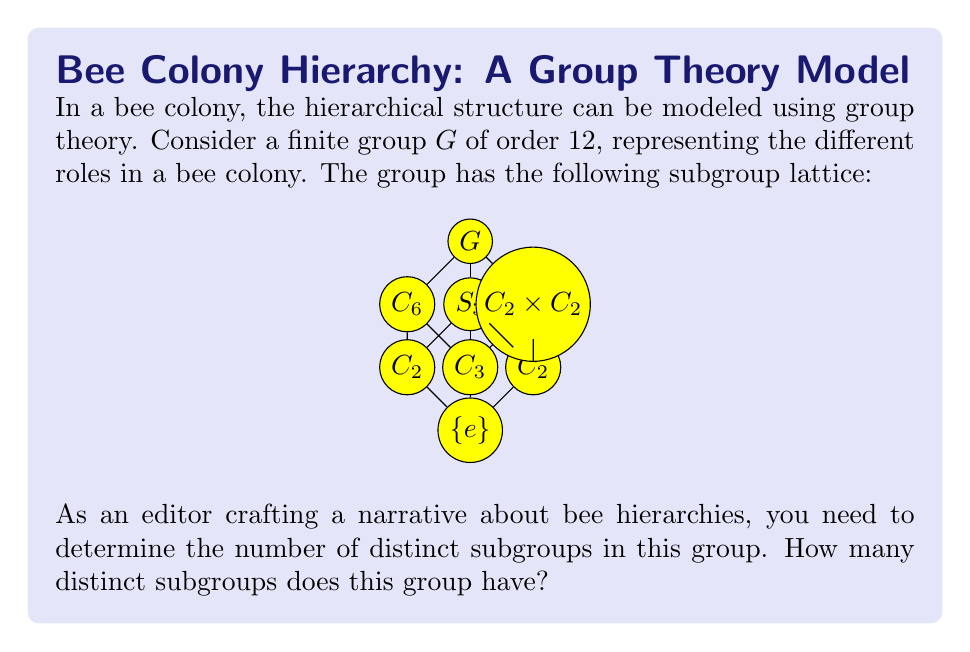Help me with this question. To solve this problem, we need to count the number of nodes in the subgroup lattice diagram. Each node represents a distinct subgroup of the group $G$. Let's count them systematically:

1. The trivial subgroup $\{e\}$ at the bottom of the lattice.
2. Three subgroups of order 2 ($C_2$): two on the second level and one on the third level.
3. One subgroup of order 3 ($C_3$) on the second level.
4. One subgroup of order 4 ($C_2 \times C_2$) on the third level.
5. One subgroup of order 6 ($C_6$) on the third level.
6. One subgroup of order 6 ($S_3$) on the third level.
7. The entire group $G$ of order 12 at the top of the lattice.

Counting these up:
$$1 + 3 + 1 + 1 + 1 + 1 + 1 = 9$$

Therefore, the group $G$ has 9 distinct subgroups.

This hierarchical structure could represent different roles in a bee colony:
- $\{e\}$: Individual bee
- $C_2$: Pair of worker bees
- $C_3$: Triad of specialized workers
- $C_2 \times C_2$: Four-bee task force
- $C_6$: Six-bee unit
- $S_3$: Specialized six-bee team
- $G$: Entire colony structure

Each subgroup represents a different level of organization within the bee colony, from individual bees to the entire colony structure.
Answer: 9 